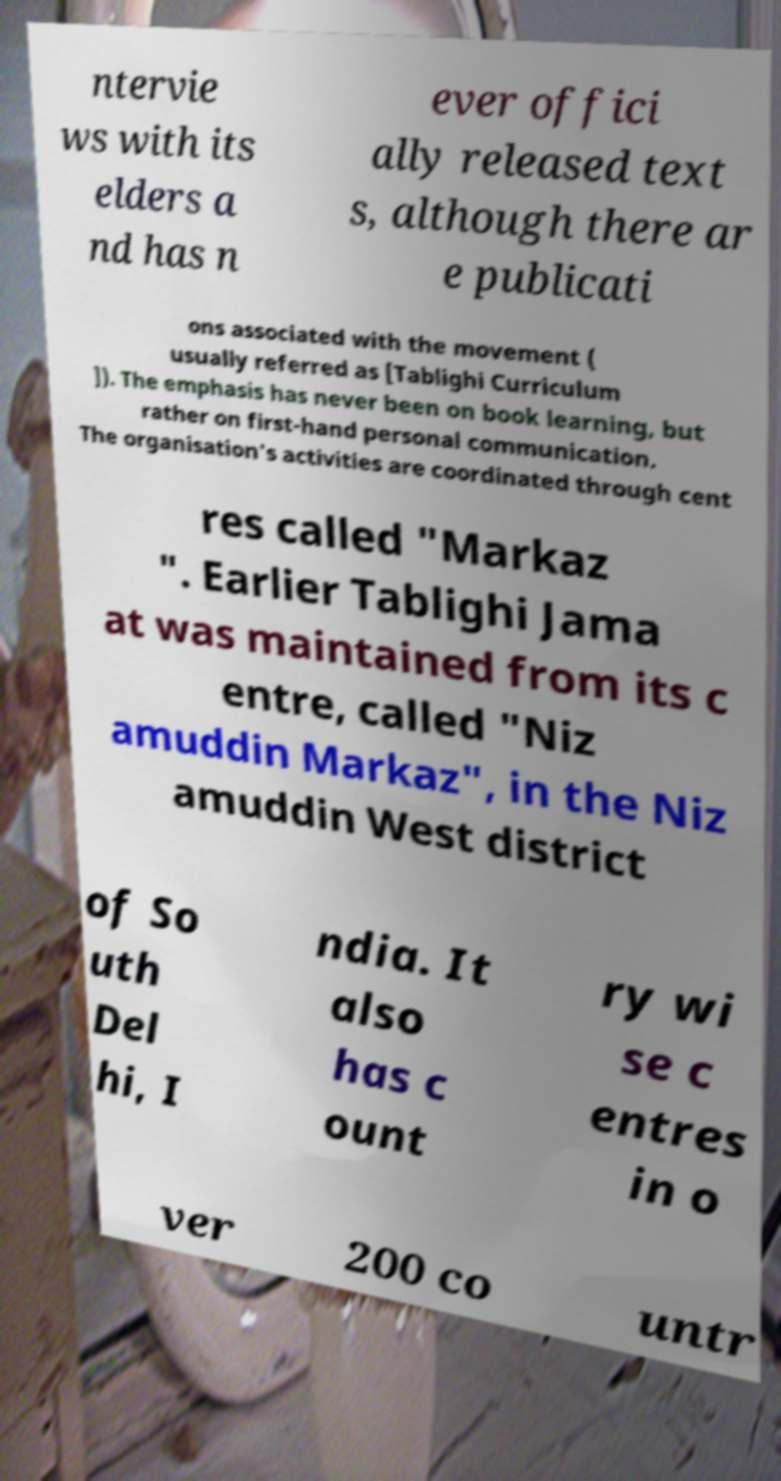Please read and relay the text visible in this image. What does it say? ntervie ws with its elders a nd has n ever offici ally released text s, although there ar e publicati ons associated with the movement ( usually referred as [Tablighi Curriculum ]). The emphasis has never been on book learning, but rather on first-hand personal communication. The organisation's activities are coordinated through cent res called "Markaz ". Earlier Tablighi Jama at was maintained from its c entre, called "Niz amuddin Markaz", in the Niz amuddin West district of So uth Del hi, I ndia. It also has c ount ry wi se c entres in o ver 200 co untr 